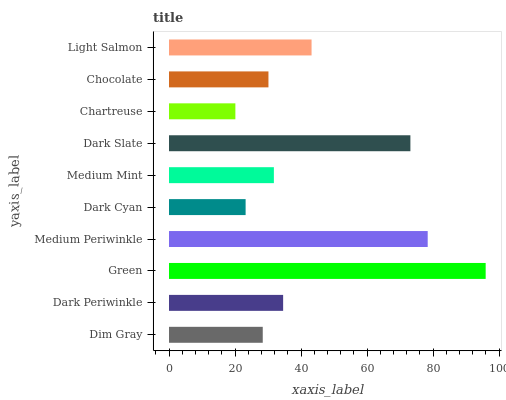Is Chartreuse the minimum?
Answer yes or no. Yes. Is Green the maximum?
Answer yes or no. Yes. Is Dark Periwinkle the minimum?
Answer yes or no. No. Is Dark Periwinkle the maximum?
Answer yes or no. No. Is Dark Periwinkle greater than Dim Gray?
Answer yes or no. Yes. Is Dim Gray less than Dark Periwinkle?
Answer yes or no. Yes. Is Dim Gray greater than Dark Periwinkle?
Answer yes or no. No. Is Dark Periwinkle less than Dim Gray?
Answer yes or no. No. Is Dark Periwinkle the high median?
Answer yes or no. Yes. Is Medium Mint the low median?
Answer yes or no. Yes. Is Dim Gray the high median?
Answer yes or no. No. Is Dark Slate the low median?
Answer yes or no. No. 